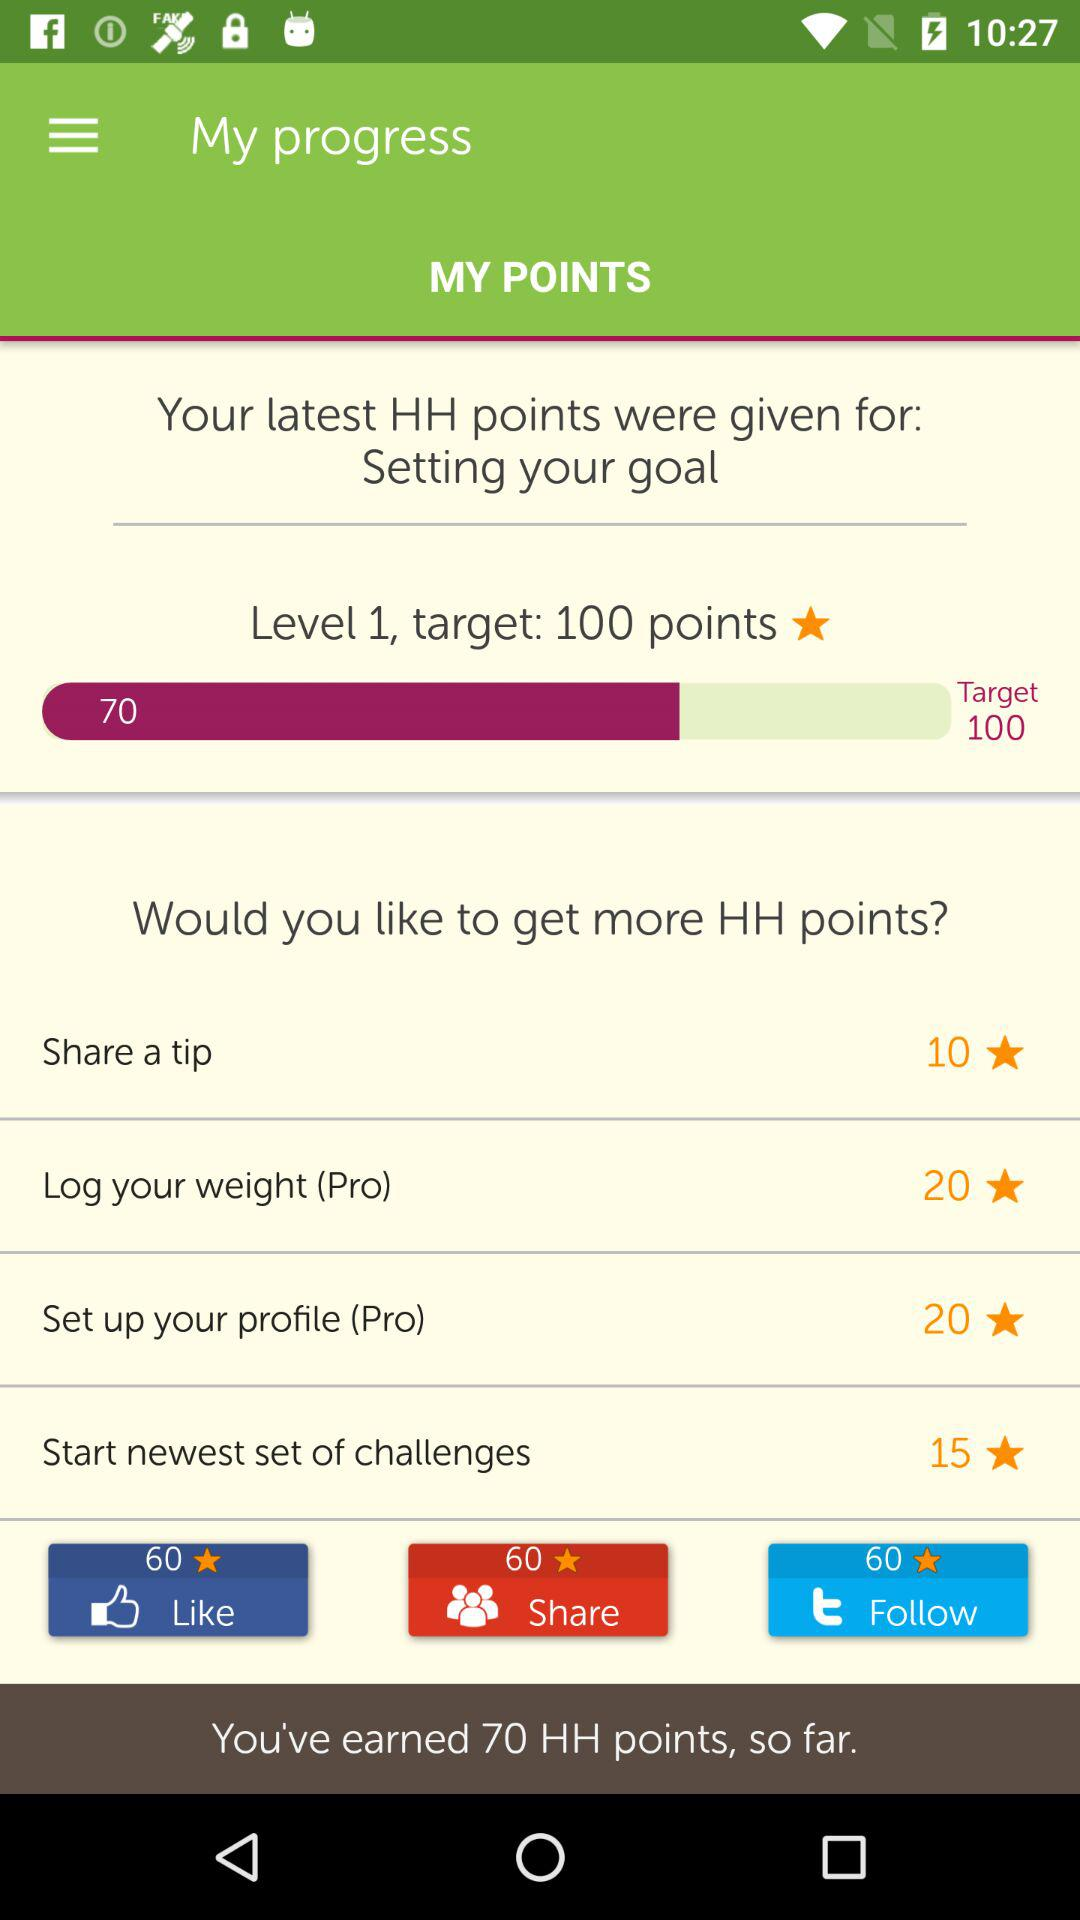How many points do I have?
Answer the question using a single word or phrase. 70 